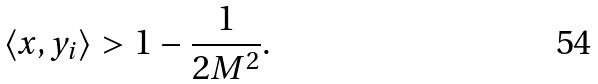<formula> <loc_0><loc_0><loc_500><loc_500>\langle x , y _ { i } \rangle > 1 - \frac { 1 } { 2 M ^ { 2 } } .</formula> 